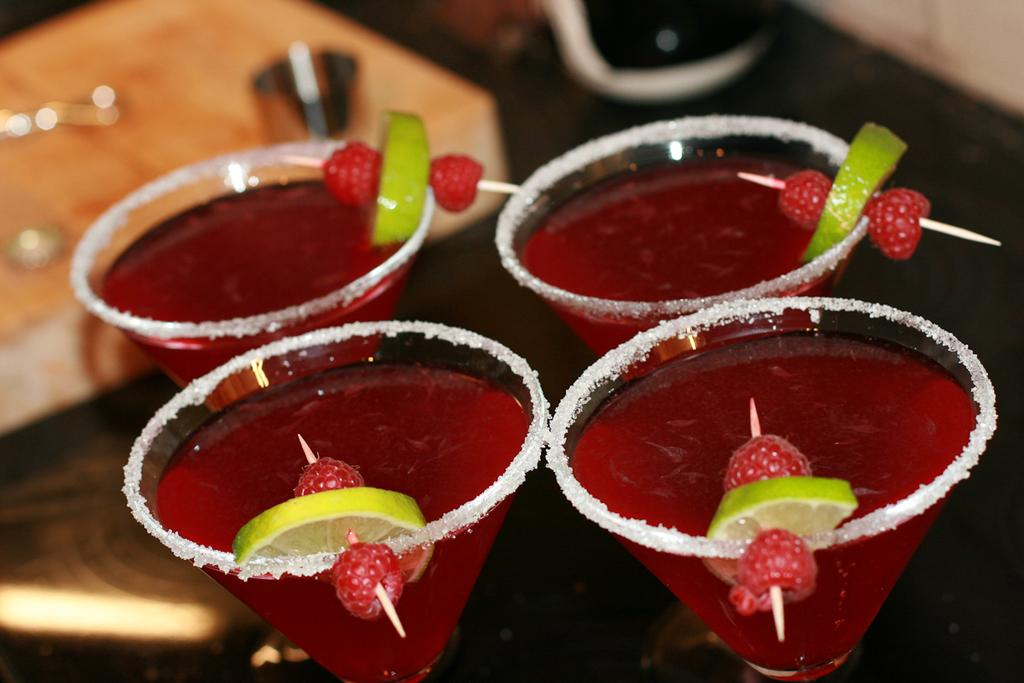What is in the glasses that are visible in the image? There are drinks in glasses in the image. What fruit can be seen in the image? There is a lemon in the image. How are the strawberries arranged in the image? The strawberries are on toothpicks in the image. What can be seen on the table in the background of the image? There are objects on the table in the background of the image. What type of crow is sitting on the wealth in the image? There is no crow or wealth present in the image. How many balloons are tied to the table in the image? There are no balloons present in the image. 